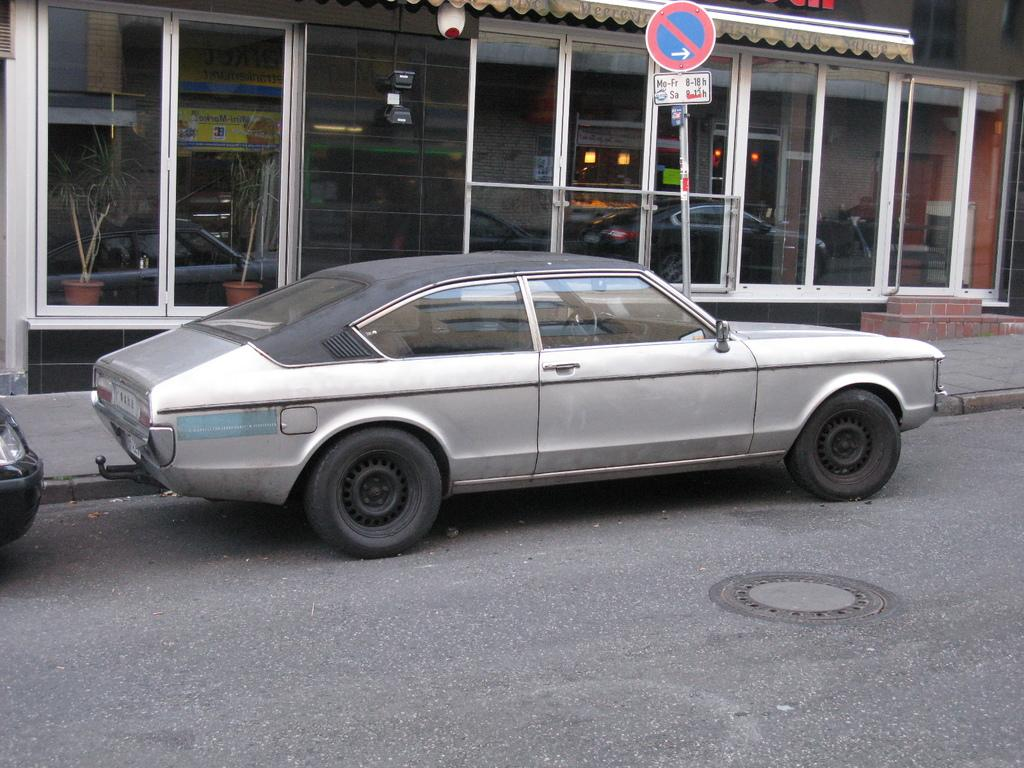What is the main subject of the image? The main subject of the image is a car. Where is the car located in relation to the showroom? The car is parked in front of a showroom. What is present beside the car? There is a footpath beside the car. What safety measure is visible on the footpath? There is a caution board on the footpath. What type of force can be seen pushing the car in the image? There is no force pushing the car in the image; it is parked and stationary. Can you see a pin holding the caution board in place in the image? There is no pin visible in the image; the caution board is standing on its own. 